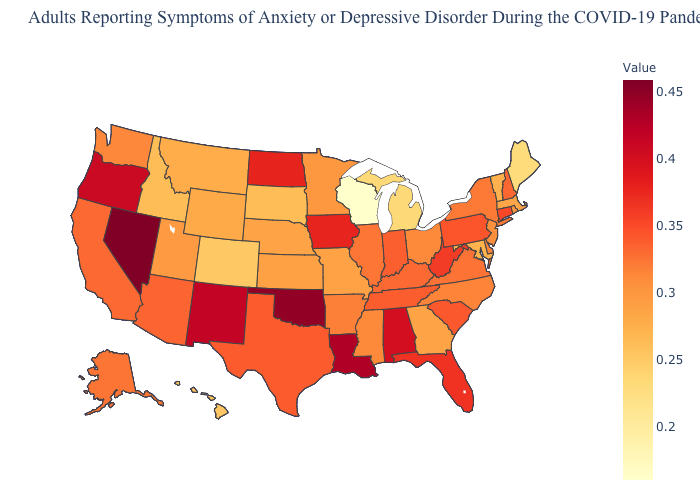Among the states that border Virginia , does North Carolina have the lowest value?
Short answer required. No. Among the states that border North Dakota , does Minnesota have the highest value?
Be succinct. Yes. Among the states that border Mississippi , which have the highest value?
Concise answer only. Louisiana. Which states have the lowest value in the USA?
Answer briefly. Wisconsin. Does Colorado have the lowest value in the West?
Answer briefly. Yes. Which states have the lowest value in the USA?
Give a very brief answer. Wisconsin. Does Maryland have the lowest value in the South?
Keep it brief. Yes. 